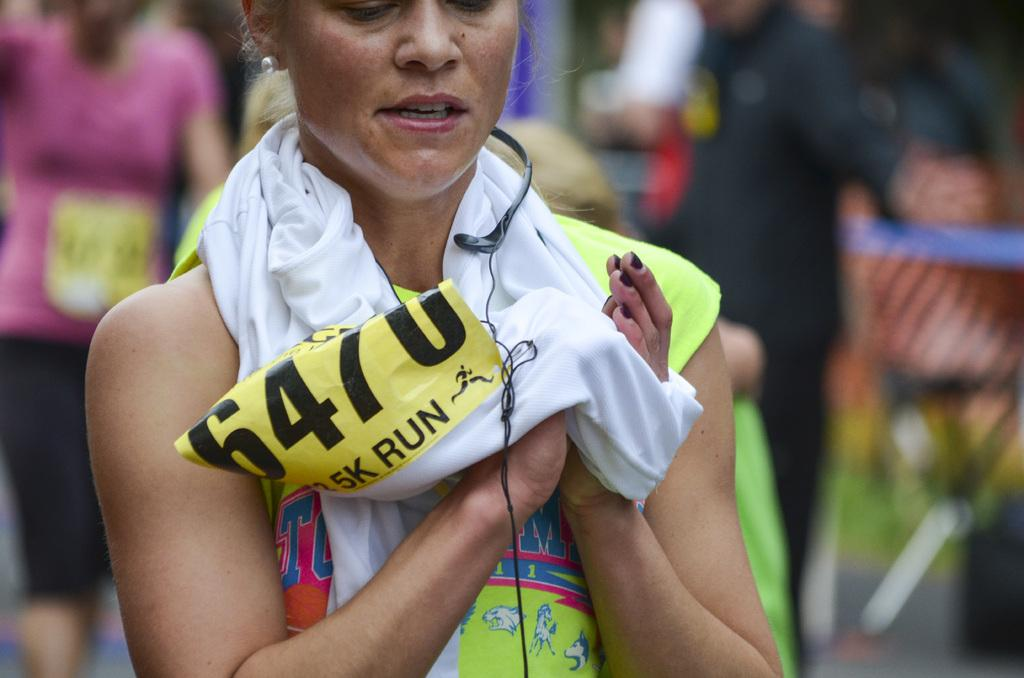Provide a one-sentence caption for the provided image. A woman with the number 6470 wiping her hands with a towel. 